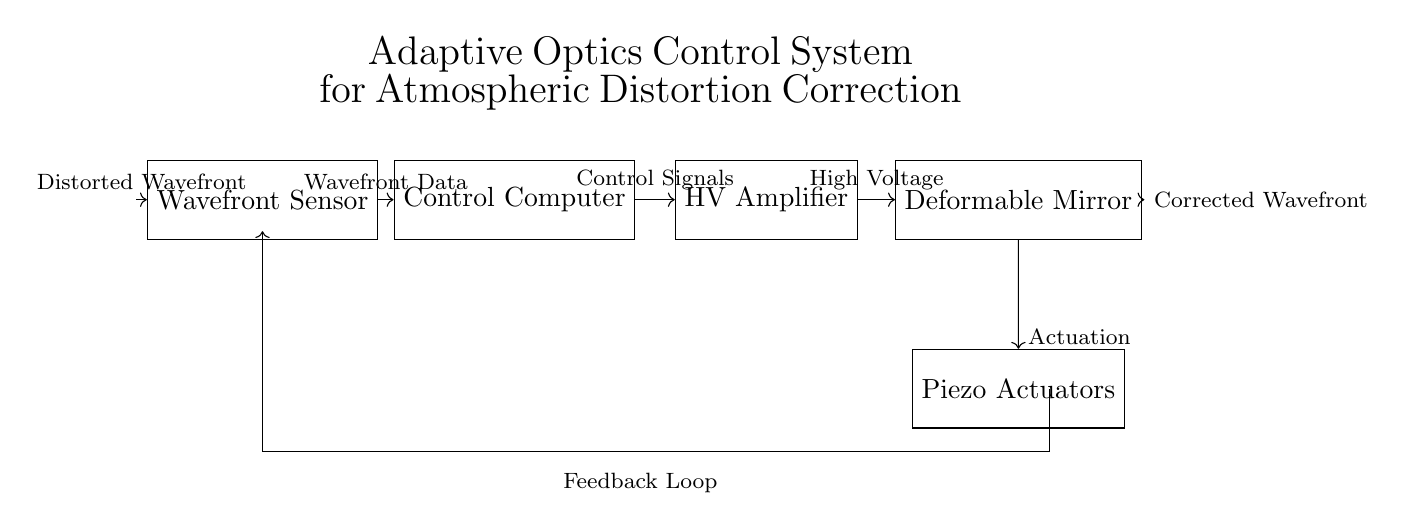What is the main purpose of this circuit? The main purpose of this circuit is to correct atmospheric distortions in light waves using adaptive optics techniques.
Answer: Correct atmospheric distortions What component generates the control signals? The component that generates the control signals is the Control Computer, which processes the data from the Wavefront Sensor.
Answer: Control Computer How many main components are there in the circuit? There are five main components: Wavefront Sensor, Control Computer, High Voltage Amplifier, Deformable Mirror, and Piezo Actuators.
Answer: Five What type of actuators are used for correction? The actuators used for correction are Piezoelectric Actuators, which are responsible for physically altering the shape of the Deformable Mirror to correct light distortions.
Answer: Piezoelectric Actuators What is the role of the High Voltage Amplifier? The role of the High Voltage Amplifier is to amplify the control signals from the Control Computer before they are sent to the Deformable Mirror for actuation.
Answer: Amplify control signals Which component receives distorted wavefront data? The component that receives distorted wavefront data is the Wavefront Sensor, which initially captures the incoming distorted light waves.
Answer: Wavefront Sensor What does the feedback loop accomplish in the circuit? The feedback loop is essential for continuously adjusting the control signals based on the performance of the Deformable Mirror to ensure accurate correction of the wavefront distortions.
Answer: Continuous adjustment 